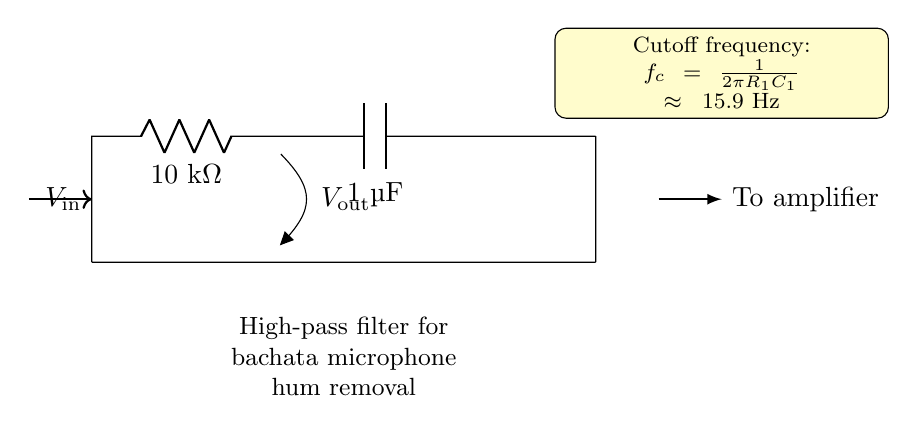What type of filter is shown in the circuit? The circuit is a high-pass filter, as indicated by the components used and their arrangement, which allows high frequency signals to pass while attenuating low frequency signals.
Answer: high-pass filter What is the value of the resistor used in the circuit? According to the diagram, the resistor R1 is specified as 10 kOhm, indicating its resistance value.
Answer: 10 kOhm What is the value of the capacitor in the circuit? The capacitor C1 is labeled as 1 µF in the circuit diagram, which means it has a capacitance of one microfarad.
Answer: 1 µF What is the cutoff frequency of this filter? The cutoff frequency is calculated using the formula based on the values of R1 and C1 provided in the diagram, resulting in approximately 15.9 Hz.
Answer: 15.9 Hz What is the function of the circuit in relation to microphone hum? The function is to remove hum, specifically in the context of bachata recordings, by allowing higher frequencies to pass and filtering out lower frequency noise.
Answer: remove hum Where does the output voltage come from in this circuit? The output voltage V_out is taken from the junction between the resistor R1 and the capacitor C1, which indicates the point of measurement for the output.
Answer: from R1 and C1 junction 